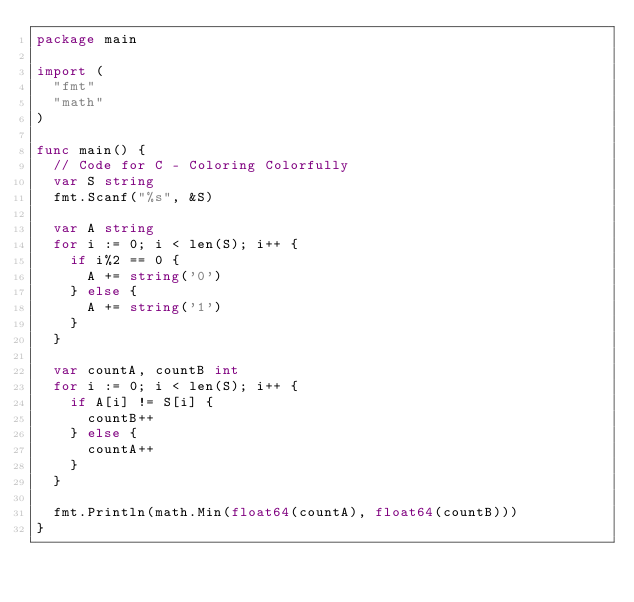<code> <loc_0><loc_0><loc_500><loc_500><_Go_>package main

import (
	"fmt"
	"math"
)

func main() {
	// Code for C - Coloring Colorfully
	var S string
	fmt.Scanf("%s", &S)

	var A string
	for i := 0; i < len(S); i++ {
		if i%2 == 0 {
			A += string('0')
		} else {
			A += string('1')
		}
	}

	var countA, countB int
	for i := 0; i < len(S); i++ {
		if A[i] != S[i] {
			countB++
		} else {
			countA++
		}
	}

	fmt.Println(math.Min(float64(countA), float64(countB)))
}
</code> 